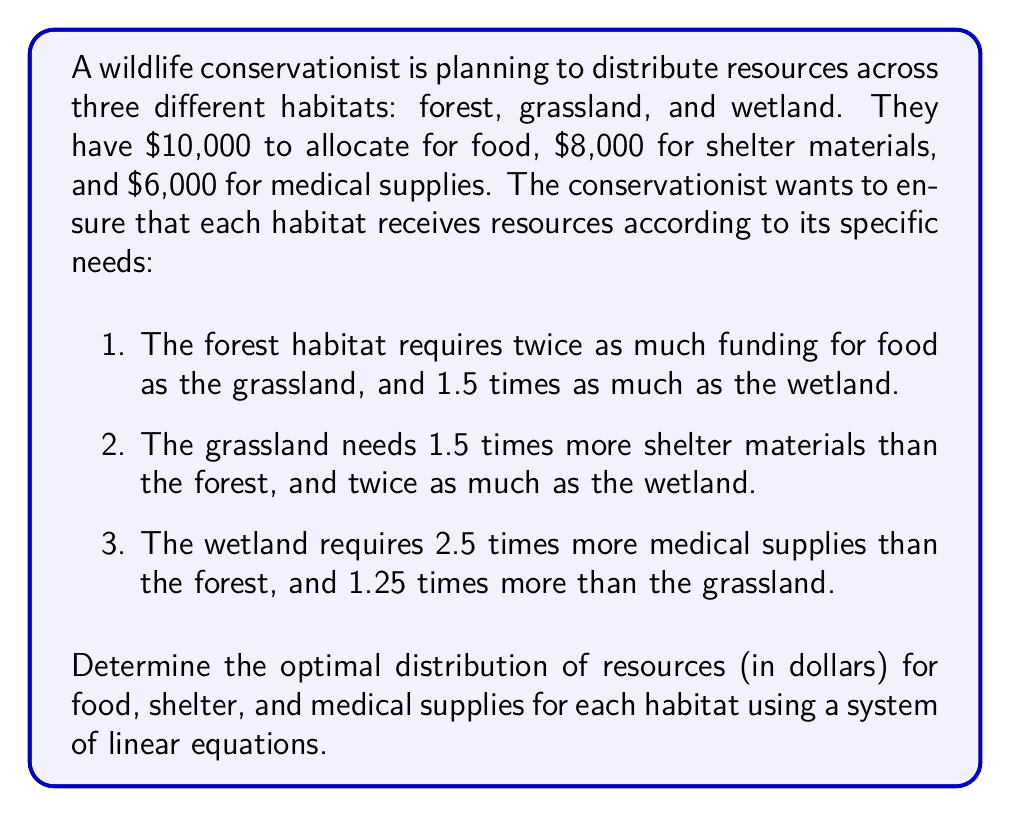Solve this math problem. Let's approach this problem step by step using a system of linear equations:

1. Define variables:
   Let $f$, $g$, and $w$ represent the amount of food funding for forest, grassland, and wetland respectively.
   Let $s_f$, $s_g$, and $s_w$ represent the amount of shelter funding for forest, grassland, and wetland respectively.
   Let $m_f$, $m_g$, and $m_w$ represent the amount of medical funding for forest, grassland, and wetland respectively.

2. Set up equations based on the given information:

   For food:
   $$f + g + w = 10000$$
   $$f = 2g$$
   $$f = 1.5w$$

   For shelter:
   $$s_f + s_g + s_w = 8000$$
   $$s_g = 1.5s_f$$
   $$s_g = 2s_w$$

   For medical supplies:
   $$m_f + m_g + m_w = 6000$$
   $$m_w = 2.5m_f$$
   $$m_w = 1.25m_g$$

3. Solve the system of equations:

   For food:
   From $f = 2g$ and $f = 1.5w$, we can deduce $2g = 1.5w$ or $w = \frac{4}{3}g$
   Substituting into the first equation:
   $$2g + g + \frac{4}{3}g = 10000$$
   $$\frac{13}{3}g = 10000$$
   $$g = \frac{30000}{13} \approx 2307.69$$
   
   Therefore:
   $$f = 2g = \frac{60000}{13} \approx 4615.38$$
   $$w = \frac{4}{3}g = \frac{40000}{13} \approx 3076.92$$

   For shelter:
   From $s_g = 1.5s_f$ and $s_g = 2s_w$, we can deduce $1.5s_f = 2s_w$ or $s_f = \frac{4}{3}s_w$
   Substituting into the first equation:
   $$\frac{4}{3}s_w + 2s_w + s_w = 8000$$
   $$\frac{13}{3}s_w = 8000$$
   $$s_w = \frac{24000}{13} \approx 1846.15$$
   
   Therefore:
   $$s_f = \frac{4}{3}s_w = \frac{32000}{13} \approx 2461.54$$
   $$s_g = 2s_w = \frac{48000}{13} \approx 3692.31$$

   For medical supplies:
   From $m_w = 2.5m_f$ and $m_w = 1.25m_g$, we can deduce $2.5m_f = 1.25m_g$ or $m_g = 2m_f$
   Substituting into the first equation:
   $$m_f + 2m_f + 2.5m_f = 6000$$
   $$5.5m_f = 6000$$
   $$m_f = \frac{6000}{5.5} \approx 1090.91$$
   
   Therefore:
   $$m_g = 2m_f = \frac{12000}{5.5} \approx 2181.82$$
   $$m_w = 2.5m_f = \frac{15000}{5.5} \approx 2727.27$$

4. Round all values to the nearest dollar for practical application.
Answer: The optimal distribution of resources (rounded to the nearest dollar) is:

Forest: $4,615 for food, $2,462 for shelter, $1,091 for medical supplies
Grassland: $2,308 for food, $3,692 for shelter, $2,182 for medical supplies
Wetland: $3,077 for food, $1,846 for shelter, $2,727 for medical supplies 